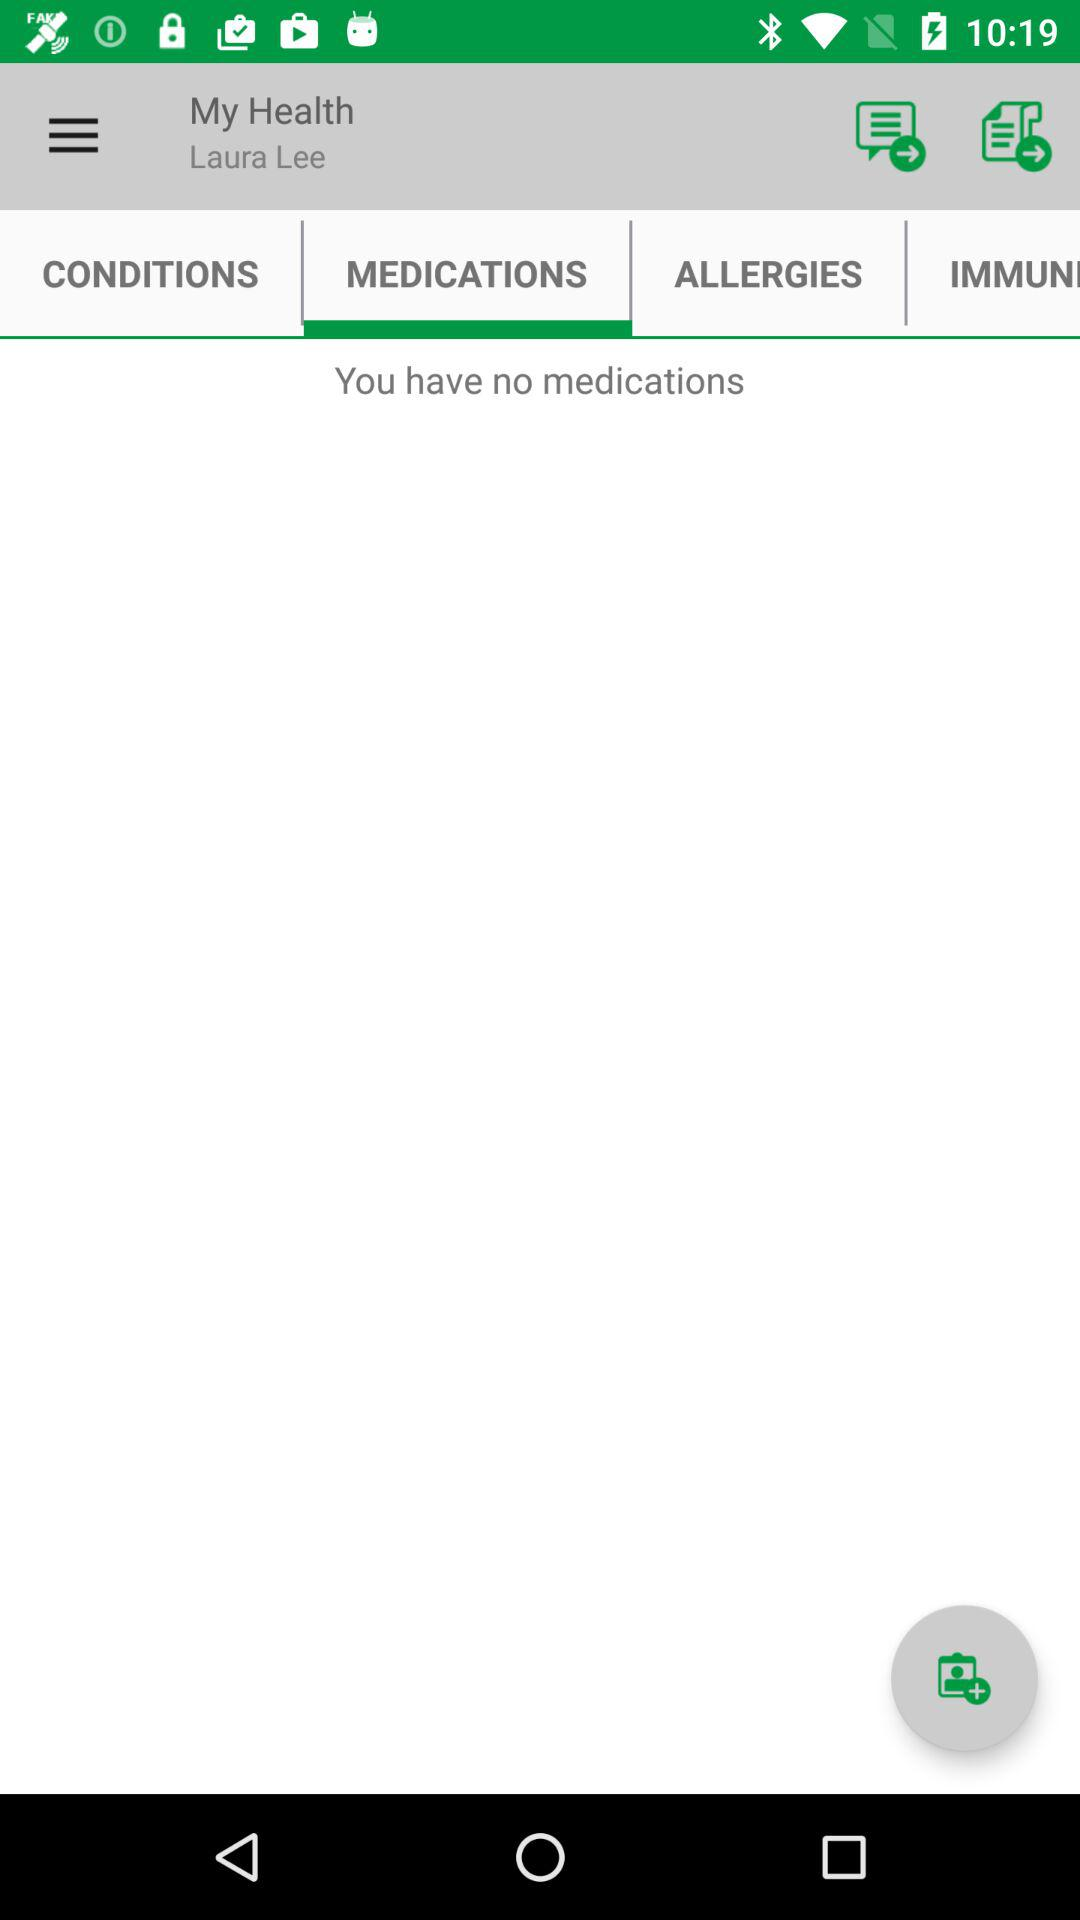Which tab is selected? The selected tab is "MEDICATIONS". 